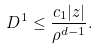<formula> <loc_0><loc_0><loc_500><loc_500>D ^ { 1 } \leq \frac { c _ { 1 } | z | } { \rho ^ { d - 1 } } .</formula> 